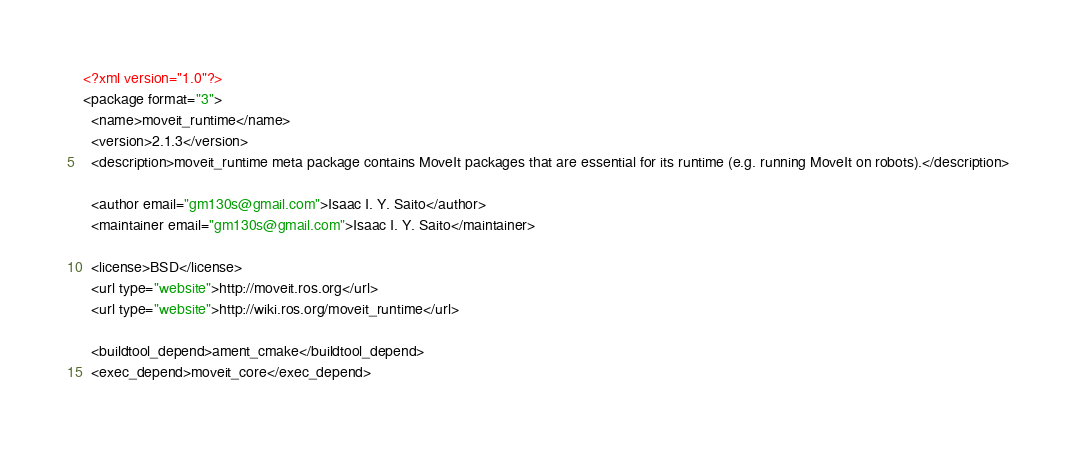Convert code to text. <code><loc_0><loc_0><loc_500><loc_500><_XML_><?xml version="1.0"?>
<package format="3">
  <name>moveit_runtime</name>
  <version>2.1.3</version>
  <description>moveit_runtime meta package contains MoveIt packages that are essential for its runtime (e.g. running MoveIt on robots).</description>

  <author email="gm130s@gmail.com">Isaac I. Y. Saito</author>
  <maintainer email="gm130s@gmail.com">Isaac I. Y. Saito</maintainer>

  <license>BSD</license>
  <url type="website">http://moveit.ros.org</url>
  <url type="website">http://wiki.ros.org/moveit_runtime</url>

  <buildtool_depend>ament_cmake</buildtool_depend>
  <exec_depend>moveit_core</exec_depend></code> 